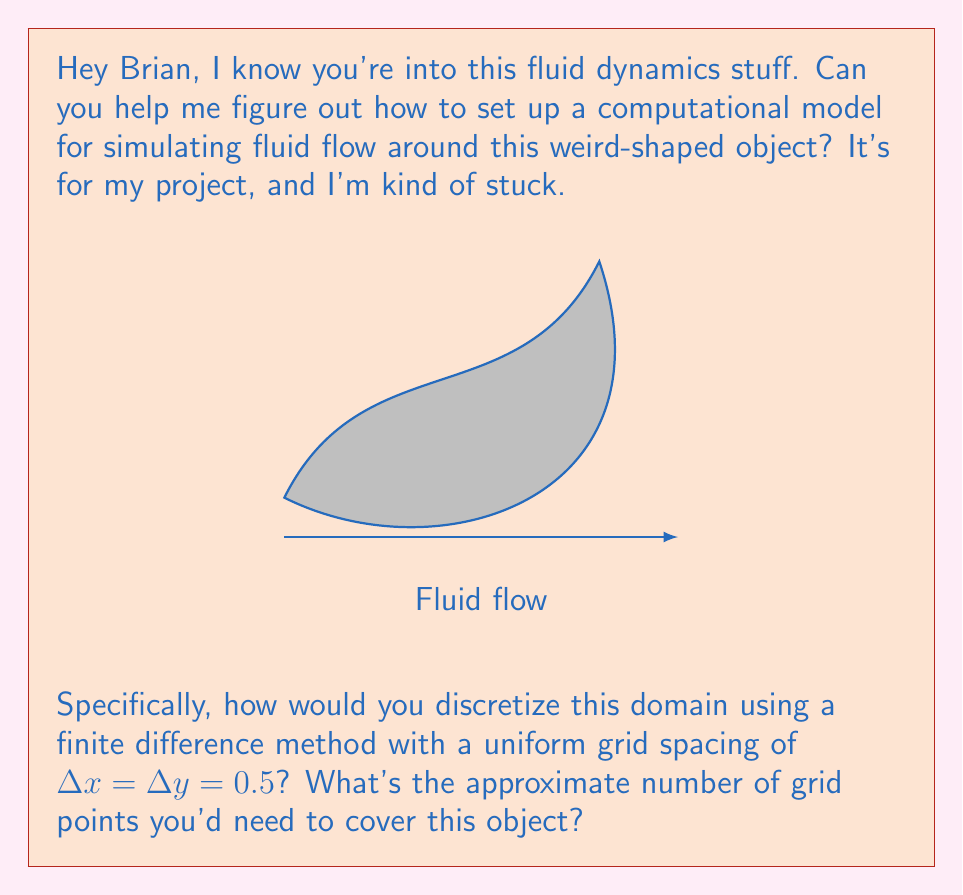Can you solve this math problem? Alright, let's break this down step-by-step:

1) First, we need to determine the bounding box of the object. From the diagram, we can estimate that the object fits within a 5x3 rectangle.

2) To cover this area with a grid of $\Delta x = \Delta y = 0.5$, we need to calculate the number of grid points in each direction:

   In x-direction: $N_x = \frac{5}{0.5} + 1 = 11$
   In y-direction: $N_y = \frac{3}{0.5} + 1 = 7$

   We add 1 to each because we need points at both ends of the interval.

3) The total number of grid points would be the product of these:

   $N_{total} = N_x \times N_y = 11 \times 7 = 77$

4) However, this includes points that are inside the object, which we don't need for fluid simulation. We need to subtract these.

5) The object covers approximately 40-50% of the bounding box. Let's estimate 45% for our calculation.

6) So, the number of grid points we actually need is approximately:

   $N_{fluid} \approx N_{total} \times (1 - 0.45) = 77 \times 0.55 \approx 42$

Therefore, we'd need approximately 42 grid points to discretize the fluid domain around this object using the specified finite difference method.
Answer: 42 grid points 